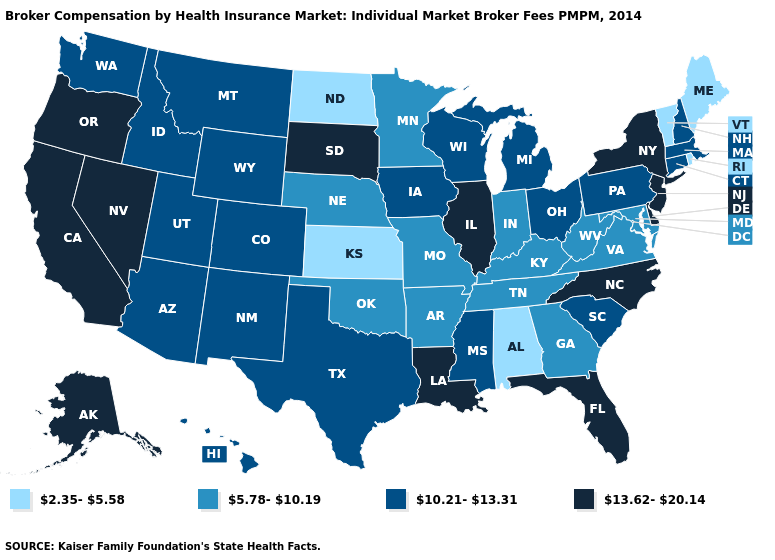What is the highest value in states that border Arkansas?
Concise answer only. 13.62-20.14. Which states have the highest value in the USA?
Concise answer only. Alaska, California, Delaware, Florida, Illinois, Louisiana, Nevada, New Jersey, New York, North Carolina, Oregon, South Dakota. Name the states that have a value in the range 10.21-13.31?
Keep it brief. Arizona, Colorado, Connecticut, Hawaii, Idaho, Iowa, Massachusetts, Michigan, Mississippi, Montana, New Hampshire, New Mexico, Ohio, Pennsylvania, South Carolina, Texas, Utah, Washington, Wisconsin, Wyoming. Does Rhode Island have the lowest value in the USA?
Answer briefly. Yes. Among the states that border Florida , which have the highest value?
Write a very short answer. Georgia. Which states have the lowest value in the South?
Concise answer only. Alabama. How many symbols are there in the legend?
Concise answer only. 4. Name the states that have a value in the range 10.21-13.31?
Short answer required. Arizona, Colorado, Connecticut, Hawaii, Idaho, Iowa, Massachusetts, Michigan, Mississippi, Montana, New Hampshire, New Mexico, Ohio, Pennsylvania, South Carolina, Texas, Utah, Washington, Wisconsin, Wyoming. What is the value of Florida?
Concise answer only. 13.62-20.14. Does Pennsylvania have a higher value than Utah?
Give a very brief answer. No. What is the highest value in states that border Nebraska?
Answer briefly. 13.62-20.14. Does the first symbol in the legend represent the smallest category?
Answer briefly. Yes. What is the value of Colorado?
Concise answer only. 10.21-13.31. 